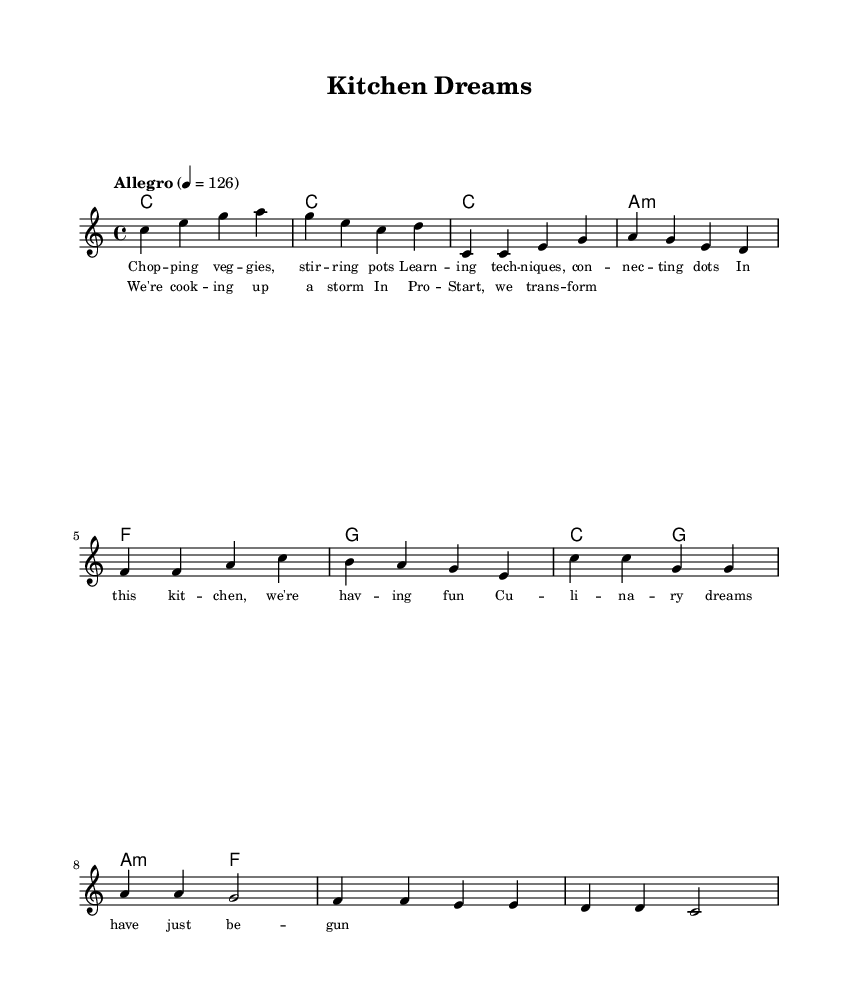What is the key signature of this music? The key signature is C major, which has no sharps or flats indicated in the music sheet's global section.
Answer: C major What is the time signature of the piece? The time signature is found in the global section and indicates that there are four beats per measure.
Answer: 4/4 What is the tempo marking of the piece? The tempo is indicated at the beginning of the global section, stating "Allegro" with a metronome marking of 126 beats per minute.
Answer: Allegro How many measures are in the verse section? The verse section consists of four measures that can be counted from the melody section starting from the note c.
Answer: 4 What are the first two words of the chorus lyrics? The chorus lyrics begin with the words "We're cook," which can be seen in the section dedicated to chorus lyrics.
Answer: We're cook What is the primary theme of the lyrics in the song? The lyrics describe culinary school experiences through various kitchen adventures, as indicated in the lyrics' focus on technique and fun in the kitchen.
Answer: Culinary school experiences What is the chord progression used in the verse? The chord progression for the verse consists of C major, A minor, F major, and G major as indicated in the harmonies section.
Answer: C, A minor, F, G 